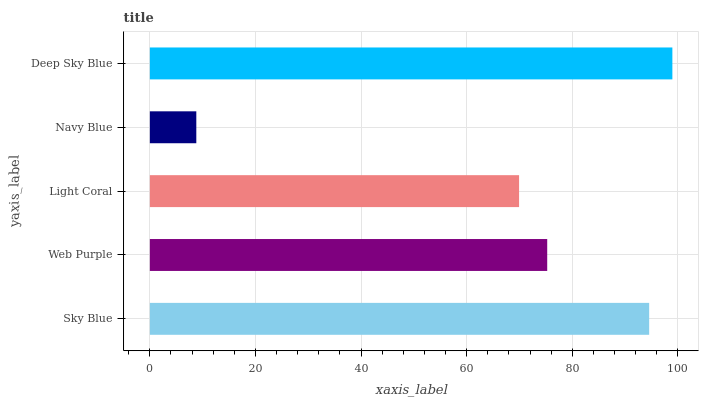Is Navy Blue the minimum?
Answer yes or no. Yes. Is Deep Sky Blue the maximum?
Answer yes or no. Yes. Is Web Purple the minimum?
Answer yes or no. No. Is Web Purple the maximum?
Answer yes or no. No. Is Sky Blue greater than Web Purple?
Answer yes or no. Yes. Is Web Purple less than Sky Blue?
Answer yes or no. Yes. Is Web Purple greater than Sky Blue?
Answer yes or no. No. Is Sky Blue less than Web Purple?
Answer yes or no. No. Is Web Purple the high median?
Answer yes or no. Yes. Is Web Purple the low median?
Answer yes or no. Yes. Is Light Coral the high median?
Answer yes or no. No. Is Light Coral the low median?
Answer yes or no. No. 